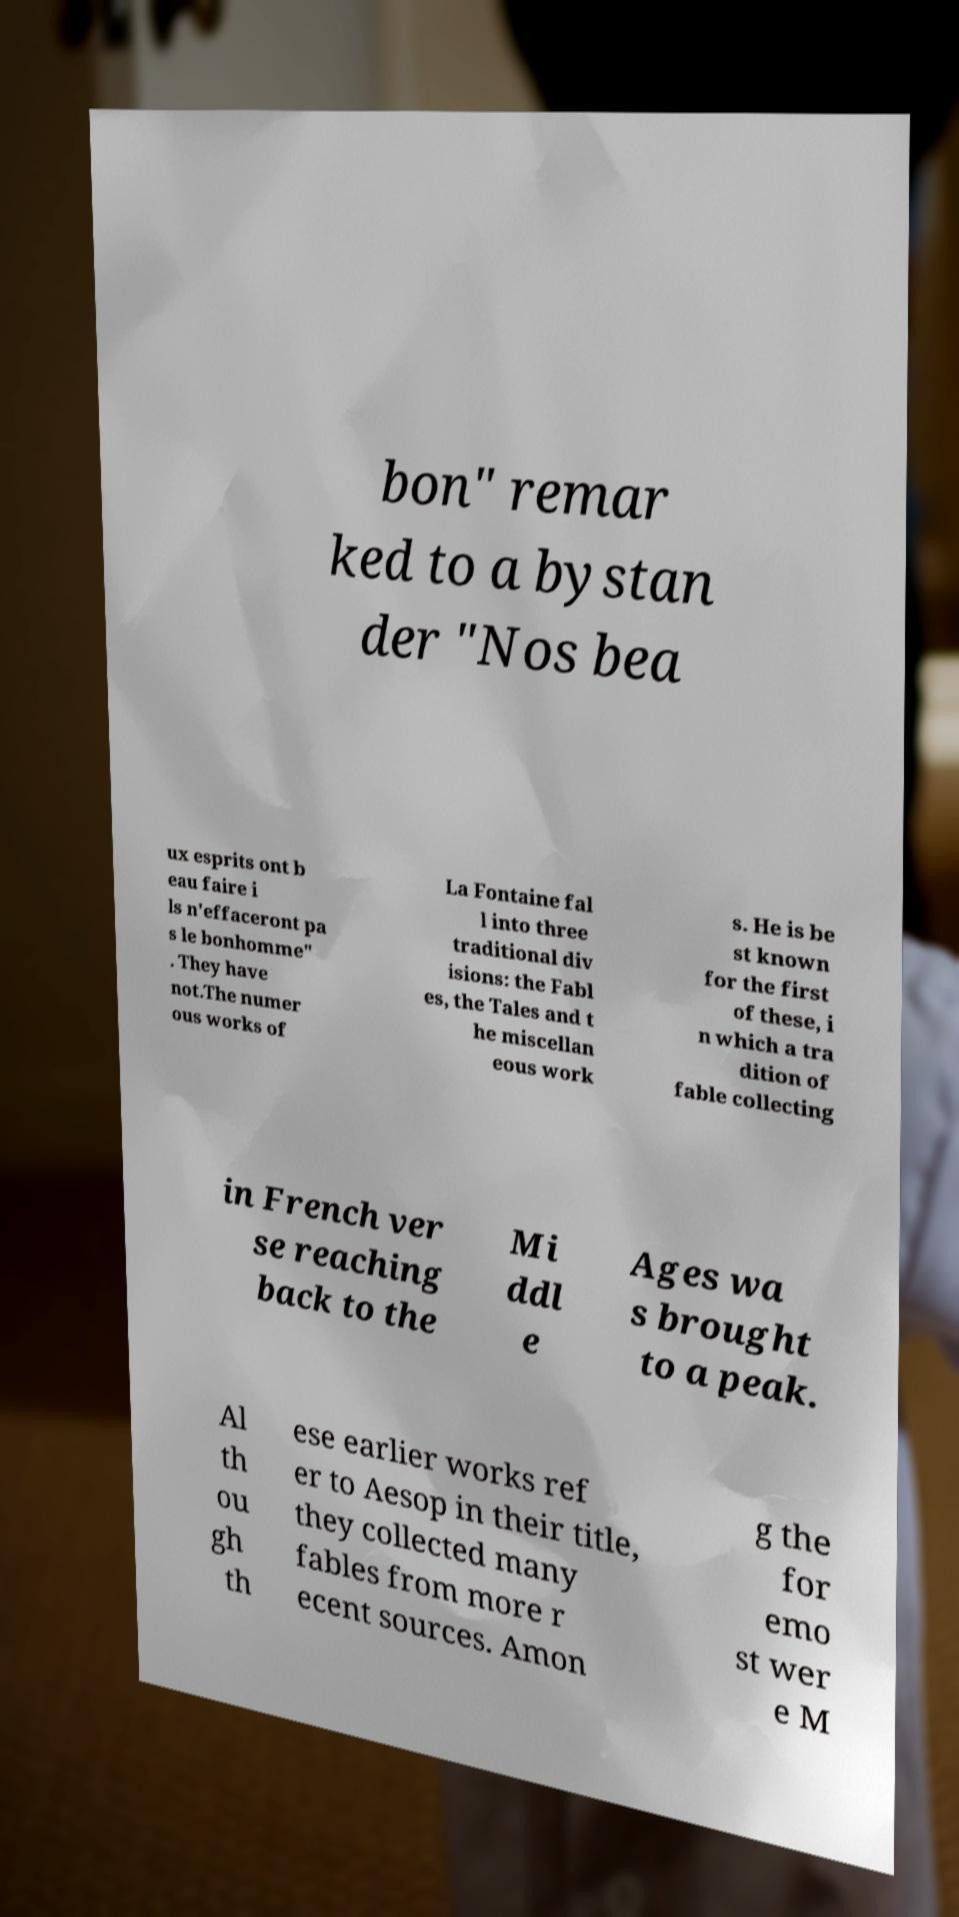What messages or text are displayed in this image? I need them in a readable, typed format. bon" remar ked to a bystan der "Nos bea ux esprits ont b eau faire i ls n'effaceront pa s le bonhomme" . They have not.The numer ous works of La Fontaine fal l into three traditional div isions: the Fabl es, the Tales and t he miscellan eous work s. He is be st known for the first of these, i n which a tra dition of fable collecting in French ver se reaching back to the Mi ddl e Ages wa s brought to a peak. Al th ou gh th ese earlier works ref er to Aesop in their title, they collected many fables from more r ecent sources. Amon g the for emo st wer e M 